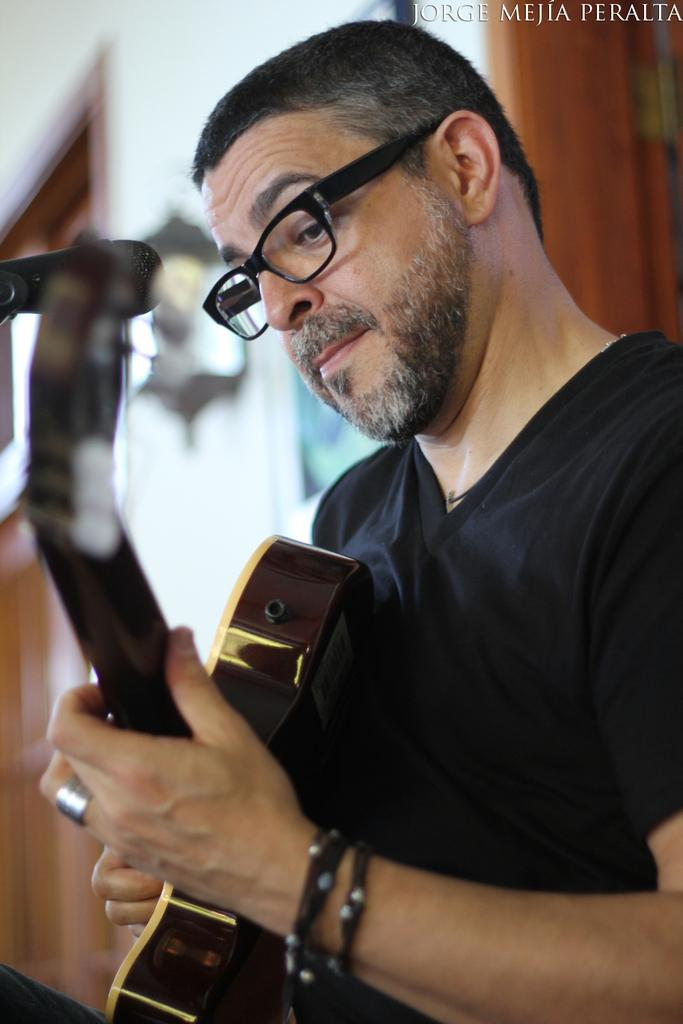Who is the person in the image? There is a man in the image. What is the man wearing? The man is wearing a black dress and black spectacles. What is the man doing in the image? The man is playing a guitar. What can be seen in the background of the image? There is a door and a white wall in the background of the image. What is on the white wall? There is a clock on the white wall. Can you tell me where the river is located in the image? There is no river present in the image. What type of nose does the man have in the image? The image does not provide enough detail to determine the man's nose type. 